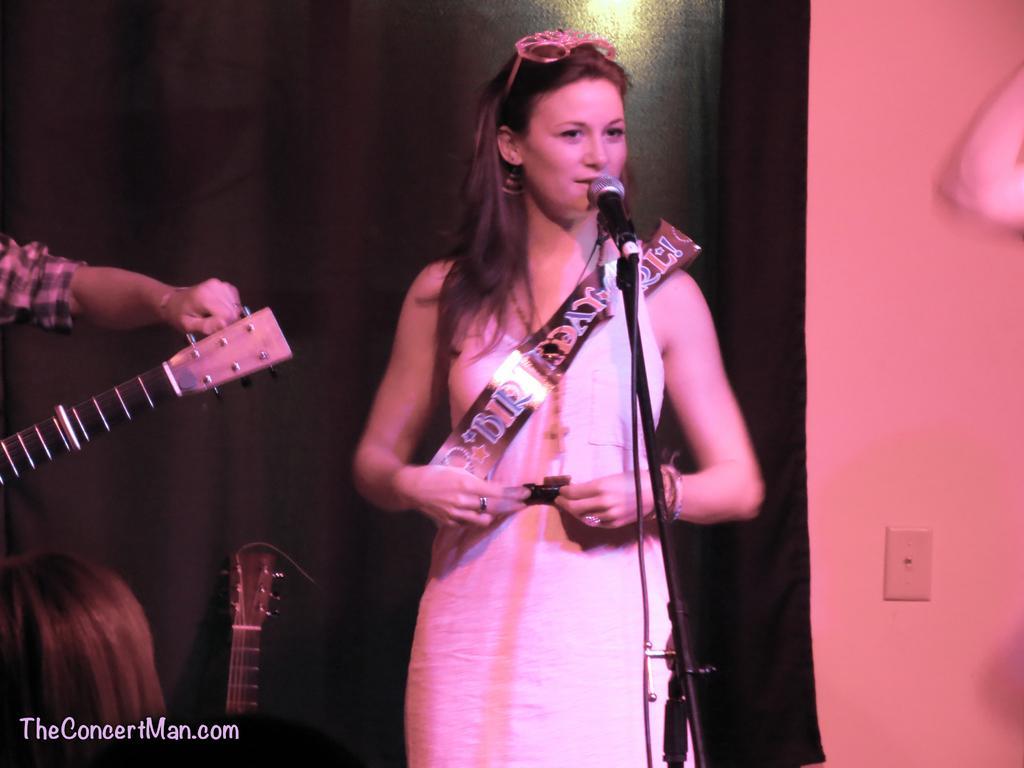Please provide a concise description of this image. A woman is standing behind a microphone. On the left there is a person holding guitar in his hand. Behind them there is a cloth and guitar. 